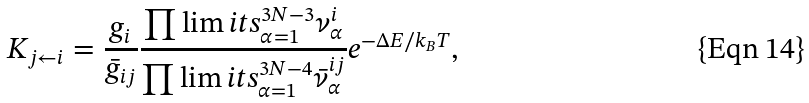<formula> <loc_0><loc_0><loc_500><loc_500>K _ { j \leftarrow i } = \frac { g _ { i } } { \bar { g } _ { i j } } \frac { \prod \lim i t s _ { \alpha = 1 } ^ { 3 N - 3 } \nu _ { \alpha } ^ { i } } { \prod \lim i t s _ { \alpha = 1 } ^ { 3 N - 4 } \bar { \nu } _ { \alpha } ^ { i j } } e ^ { - \Delta E / k _ { B } T } ,</formula> 